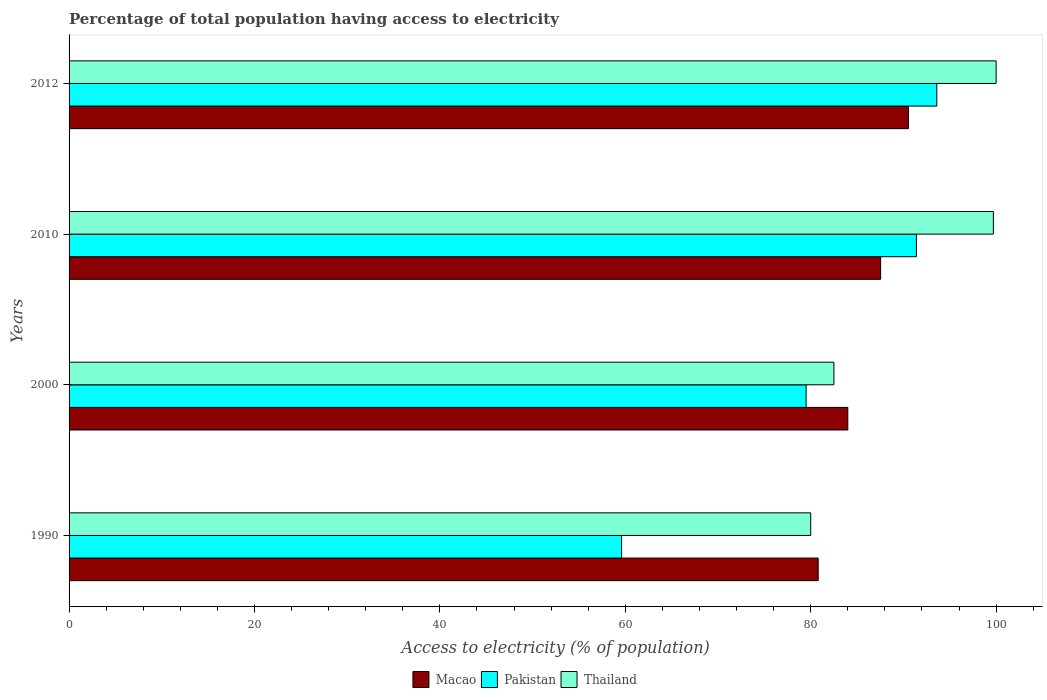How many groups of bars are there?
Provide a succinct answer. 4. Are the number of bars per tick equal to the number of legend labels?
Provide a short and direct response. Yes. Are the number of bars on each tick of the Y-axis equal?
Offer a very short reply. Yes. How many bars are there on the 3rd tick from the top?
Keep it short and to the point. 3. How many bars are there on the 2nd tick from the bottom?
Keep it short and to the point. 3. What is the label of the 3rd group of bars from the top?
Provide a short and direct response. 2000. In how many cases, is the number of bars for a given year not equal to the number of legend labels?
Keep it short and to the point. 0. What is the percentage of population that have access to electricity in Pakistan in 2000?
Give a very brief answer. 79.5. Across all years, what is the maximum percentage of population that have access to electricity in Macao?
Offer a terse response. 90.54. Across all years, what is the minimum percentage of population that have access to electricity in Macao?
Offer a terse response. 80.8. In which year was the percentage of population that have access to electricity in Macao minimum?
Offer a very short reply. 1990. What is the total percentage of population that have access to electricity in Pakistan in the graph?
Your answer should be very brief. 324.1. What is the difference between the percentage of population that have access to electricity in Macao in 2010 and that in 2012?
Give a very brief answer. -3. What is the difference between the percentage of population that have access to electricity in Pakistan in 1990 and the percentage of population that have access to electricity in Thailand in 2000?
Offer a very short reply. -22.9. What is the average percentage of population that have access to electricity in Pakistan per year?
Your answer should be compact. 81.03. In the year 2012, what is the difference between the percentage of population that have access to electricity in Pakistan and percentage of population that have access to electricity in Macao?
Give a very brief answer. 3.06. In how many years, is the percentage of population that have access to electricity in Thailand greater than 64 %?
Provide a succinct answer. 4. What is the ratio of the percentage of population that have access to electricity in Thailand in 1990 to that in 2000?
Provide a short and direct response. 0.97. Is the difference between the percentage of population that have access to electricity in Pakistan in 2000 and 2012 greater than the difference between the percentage of population that have access to electricity in Macao in 2000 and 2012?
Make the answer very short. No. What is the difference between the highest and the second highest percentage of population that have access to electricity in Pakistan?
Make the answer very short. 2.2. What is the difference between the highest and the lowest percentage of population that have access to electricity in Macao?
Offer a very short reply. 9.74. In how many years, is the percentage of population that have access to electricity in Macao greater than the average percentage of population that have access to electricity in Macao taken over all years?
Your answer should be compact. 2. Is the sum of the percentage of population that have access to electricity in Pakistan in 1990 and 2012 greater than the maximum percentage of population that have access to electricity in Macao across all years?
Make the answer very short. Yes. What does the 2nd bar from the top in 2012 represents?
Ensure brevity in your answer.  Pakistan. Is it the case that in every year, the sum of the percentage of population that have access to electricity in Macao and percentage of population that have access to electricity in Thailand is greater than the percentage of population that have access to electricity in Pakistan?
Ensure brevity in your answer.  Yes. How many bars are there?
Make the answer very short. 12. Are all the bars in the graph horizontal?
Your answer should be very brief. Yes. Are the values on the major ticks of X-axis written in scientific E-notation?
Keep it short and to the point. No. Does the graph contain grids?
Your response must be concise. No. How many legend labels are there?
Your response must be concise. 3. How are the legend labels stacked?
Keep it short and to the point. Horizontal. What is the title of the graph?
Your answer should be compact. Percentage of total population having access to electricity. Does "West Bank and Gaza" appear as one of the legend labels in the graph?
Provide a succinct answer. No. What is the label or title of the X-axis?
Offer a very short reply. Access to electricity (% of population). What is the label or title of the Y-axis?
Your answer should be very brief. Years. What is the Access to electricity (% of population) of Macao in 1990?
Offer a very short reply. 80.8. What is the Access to electricity (% of population) of Pakistan in 1990?
Your answer should be very brief. 59.6. What is the Access to electricity (% of population) of Thailand in 1990?
Provide a succinct answer. 80. What is the Access to electricity (% of population) in Pakistan in 2000?
Provide a short and direct response. 79.5. What is the Access to electricity (% of population) of Thailand in 2000?
Your response must be concise. 82.5. What is the Access to electricity (% of population) in Macao in 2010?
Keep it short and to the point. 87.54. What is the Access to electricity (% of population) of Pakistan in 2010?
Offer a very short reply. 91.4. What is the Access to electricity (% of population) of Thailand in 2010?
Make the answer very short. 99.7. What is the Access to electricity (% of population) of Macao in 2012?
Provide a short and direct response. 90.54. What is the Access to electricity (% of population) of Pakistan in 2012?
Offer a terse response. 93.6. Across all years, what is the maximum Access to electricity (% of population) in Macao?
Your answer should be very brief. 90.54. Across all years, what is the maximum Access to electricity (% of population) of Pakistan?
Provide a succinct answer. 93.6. Across all years, what is the minimum Access to electricity (% of population) in Macao?
Provide a short and direct response. 80.8. Across all years, what is the minimum Access to electricity (% of population) of Pakistan?
Ensure brevity in your answer.  59.6. Across all years, what is the minimum Access to electricity (% of population) in Thailand?
Offer a very short reply. 80. What is the total Access to electricity (% of population) in Macao in the graph?
Make the answer very short. 342.89. What is the total Access to electricity (% of population) in Pakistan in the graph?
Give a very brief answer. 324.1. What is the total Access to electricity (% of population) in Thailand in the graph?
Offer a terse response. 362.2. What is the difference between the Access to electricity (% of population) of Macao in 1990 and that in 2000?
Offer a terse response. -3.2. What is the difference between the Access to electricity (% of population) of Pakistan in 1990 and that in 2000?
Your answer should be very brief. -19.9. What is the difference between the Access to electricity (% of population) in Macao in 1990 and that in 2010?
Offer a very short reply. -6.74. What is the difference between the Access to electricity (% of population) of Pakistan in 1990 and that in 2010?
Your answer should be compact. -31.8. What is the difference between the Access to electricity (% of population) in Thailand in 1990 and that in 2010?
Offer a very short reply. -19.7. What is the difference between the Access to electricity (% of population) of Macao in 1990 and that in 2012?
Provide a short and direct response. -9.74. What is the difference between the Access to electricity (% of population) of Pakistan in 1990 and that in 2012?
Your response must be concise. -34. What is the difference between the Access to electricity (% of population) in Thailand in 1990 and that in 2012?
Offer a very short reply. -20. What is the difference between the Access to electricity (% of population) of Macao in 2000 and that in 2010?
Ensure brevity in your answer.  -3.54. What is the difference between the Access to electricity (% of population) in Pakistan in 2000 and that in 2010?
Give a very brief answer. -11.9. What is the difference between the Access to electricity (% of population) in Thailand in 2000 and that in 2010?
Offer a terse response. -17.2. What is the difference between the Access to electricity (% of population) in Macao in 2000 and that in 2012?
Make the answer very short. -6.54. What is the difference between the Access to electricity (% of population) of Pakistan in 2000 and that in 2012?
Offer a very short reply. -14.1. What is the difference between the Access to electricity (% of population) of Thailand in 2000 and that in 2012?
Your answer should be compact. -17.5. What is the difference between the Access to electricity (% of population) in Macao in 2010 and that in 2012?
Your answer should be compact. -3. What is the difference between the Access to electricity (% of population) in Pakistan in 2010 and that in 2012?
Provide a succinct answer. -2.2. What is the difference between the Access to electricity (% of population) in Thailand in 2010 and that in 2012?
Your answer should be very brief. -0.3. What is the difference between the Access to electricity (% of population) of Macao in 1990 and the Access to electricity (% of population) of Pakistan in 2000?
Your answer should be compact. 1.3. What is the difference between the Access to electricity (% of population) in Macao in 1990 and the Access to electricity (% of population) in Thailand in 2000?
Give a very brief answer. -1.7. What is the difference between the Access to electricity (% of population) in Pakistan in 1990 and the Access to electricity (% of population) in Thailand in 2000?
Keep it short and to the point. -22.9. What is the difference between the Access to electricity (% of population) of Macao in 1990 and the Access to electricity (% of population) of Pakistan in 2010?
Keep it short and to the point. -10.6. What is the difference between the Access to electricity (% of population) in Macao in 1990 and the Access to electricity (% of population) in Thailand in 2010?
Ensure brevity in your answer.  -18.9. What is the difference between the Access to electricity (% of population) of Pakistan in 1990 and the Access to electricity (% of population) of Thailand in 2010?
Give a very brief answer. -40.1. What is the difference between the Access to electricity (% of population) in Macao in 1990 and the Access to electricity (% of population) in Pakistan in 2012?
Offer a very short reply. -12.8. What is the difference between the Access to electricity (% of population) of Macao in 1990 and the Access to electricity (% of population) of Thailand in 2012?
Make the answer very short. -19.2. What is the difference between the Access to electricity (% of population) of Pakistan in 1990 and the Access to electricity (% of population) of Thailand in 2012?
Offer a very short reply. -40.4. What is the difference between the Access to electricity (% of population) of Macao in 2000 and the Access to electricity (% of population) of Thailand in 2010?
Provide a short and direct response. -15.7. What is the difference between the Access to electricity (% of population) in Pakistan in 2000 and the Access to electricity (% of population) in Thailand in 2010?
Keep it short and to the point. -20.2. What is the difference between the Access to electricity (% of population) of Macao in 2000 and the Access to electricity (% of population) of Pakistan in 2012?
Give a very brief answer. -9.6. What is the difference between the Access to electricity (% of population) in Pakistan in 2000 and the Access to electricity (% of population) in Thailand in 2012?
Offer a very short reply. -20.5. What is the difference between the Access to electricity (% of population) in Macao in 2010 and the Access to electricity (% of population) in Pakistan in 2012?
Your response must be concise. -6.06. What is the difference between the Access to electricity (% of population) in Macao in 2010 and the Access to electricity (% of population) in Thailand in 2012?
Your answer should be compact. -12.46. What is the average Access to electricity (% of population) of Macao per year?
Keep it short and to the point. 85.72. What is the average Access to electricity (% of population) of Pakistan per year?
Ensure brevity in your answer.  81.03. What is the average Access to electricity (% of population) in Thailand per year?
Offer a terse response. 90.55. In the year 1990, what is the difference between the Access to electricity (% of population) of Macao and Access to electricity (% of population) of Pakistan?
Give a very brief answer. 21.2. In the year 1990, what is the difference between the Access to electricity (% of population) in Macao and Access to electricity (% of population) in Thailand?
Your answer should be compact. 0.8. In the year 1990, what is the difference between the Access to electricity (% of population) in Pakistan and Access to electricity (% of population) in Thailand?
Offer a terse response. -20.4. In the year 2000, what is the difference between the Access to electricity (% of population) of Macao and Access to electricity (% of population) of Pakistan?
Your answer should be compact. 4.5. In the year 2000, what is the difference between the Access to electricity (% of population) in Macao and Access to electricity (% of population) in Thailand?
Give a very brief answer. 1.5. In the year 2000, what is the difference between the Access to electricity (% of population) in Pakistan and Access to electricity (% of population) in Thailand?
Your answer should be very brief. -3. In the year 2010, what is the difference between the Access to electricity (% of population) of Macao and Access to electricity (% of population) of Pakistan?
Offer a very short reply. -3.86. In the year 2010, what is the difference between the Access to electricity (% of population) in Macao and Access to electricity (% of population) in Thailand?
Provide a succinct answer. -12.16. In the year 2010, what is the difference between the Access to electricity (% of population) in Pakistan and Access to electricity (% of population) in Thailand?
Offer a terse response. -8.3. In the year 2012, what is the difference between the Access to electricity (% of population) of Macao and Access to electricity (% of population) of Pakistan?
Provide a short and direct response. -3.06. In the year 2012, what is the difference between the Access to electricity (% of population) in Macao and Access to electricity (% of population) in Thailand?
Give a very brief answer. -9.46. What is the ratio of the Access to electricity (% of population) of Macao in 1990 to that in 2000?
Your response must be concise. 0.96. What is the ratio of the Access to electricity (% of population) of Pakistan in 1990 to that in 2000?
Your answer should be compact. 0.75. What is the ratio of the Access to electricity (% of population) of Thailand in 1990 to that in 2000?
Give a very brief answer. 0.97. What is the ratio of the Access to electricity (% of population) in Macao in 1990 to that in 2010?
Offer a very short reply. 0.92. What is the ratio of the Access to electricity (% of population) of Pakistan in 1990 to that in 2010?
Your answer should be very brief. 0.65. What is the ratio of the Access to electricity (% of population) of Thailand in 1990 to that in 2010?
Ensure brevity in your answer.  0.8. What is the ratio of the Access to electricity (% of population) of Macao in 1990 to that in 2012?
Keep it short and to the point. 0.89. What is the ratio of the Access to electricity (% of population) of Pakistan in 1990 to that in 2012?
Provide a succinct answer. 0.64. What is the ratio of the Access to electricity (% of population) in Thailand in 1990 to that in 2012?
Your answer should be compact. 0.8. What is the ratio of the Access to electricity (% of population) of Macao in 2000 to that in 2010?
Ensure brevity in your answer.  0.96. What is the ratio of the Access to electricity (% of population) in Pakistan in 2000 to that in 2010?
Make the answer very short. 0.87. What is the ratio of the Access to electricity (% of population) in Thailand in 2000 to that in 2010?
Provide a short and direct response. 0.83. What is the ratio of the Access to electricity (% of population) of Macao in 2000 to that in 2012?
Provide a succinct answer. 0.93. What is the ratio of the Access to electricity (% of population) in Pakistan in 2000 to that in 2012?
Provide a succinct answer. 0.85. What is the ratio of the Access to electricity (% of population) of Thailand in 2000 to that in 2012?
Your answer should be compact. 0.82. What is the ratio of the Access to electricity (% of population) of Macao in 2010 to that in 2012?
Offer a terse response. 0.97. What is the ratio of the Access to electricity (% of population) in Pakistan in 2010 to that in 2012?
Your answer should be compact. 0.98. What is the ratio of the Access to electricity (% of population) of Thailand in 2010 to that in 2012?
Ensure brevity in your answer.  1. What is the difference between the highest and the second highest Access to electricity (% of population) of Macao?
Ensure brevity in your answer.  3. What is the difference between the highest and the lowest Access to electricity (% of population) in Macao?
Make the answer very short. 9.74. What is the difference between the highest and the lowest Access to electricity (% of population) of Pakistan?
Make the answer very short. 34. 